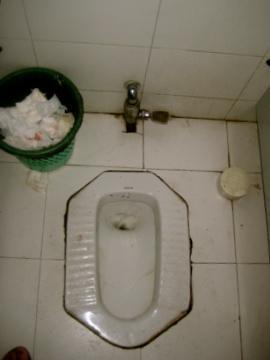How many toilets are there?
Give a very brief answer. 1. 